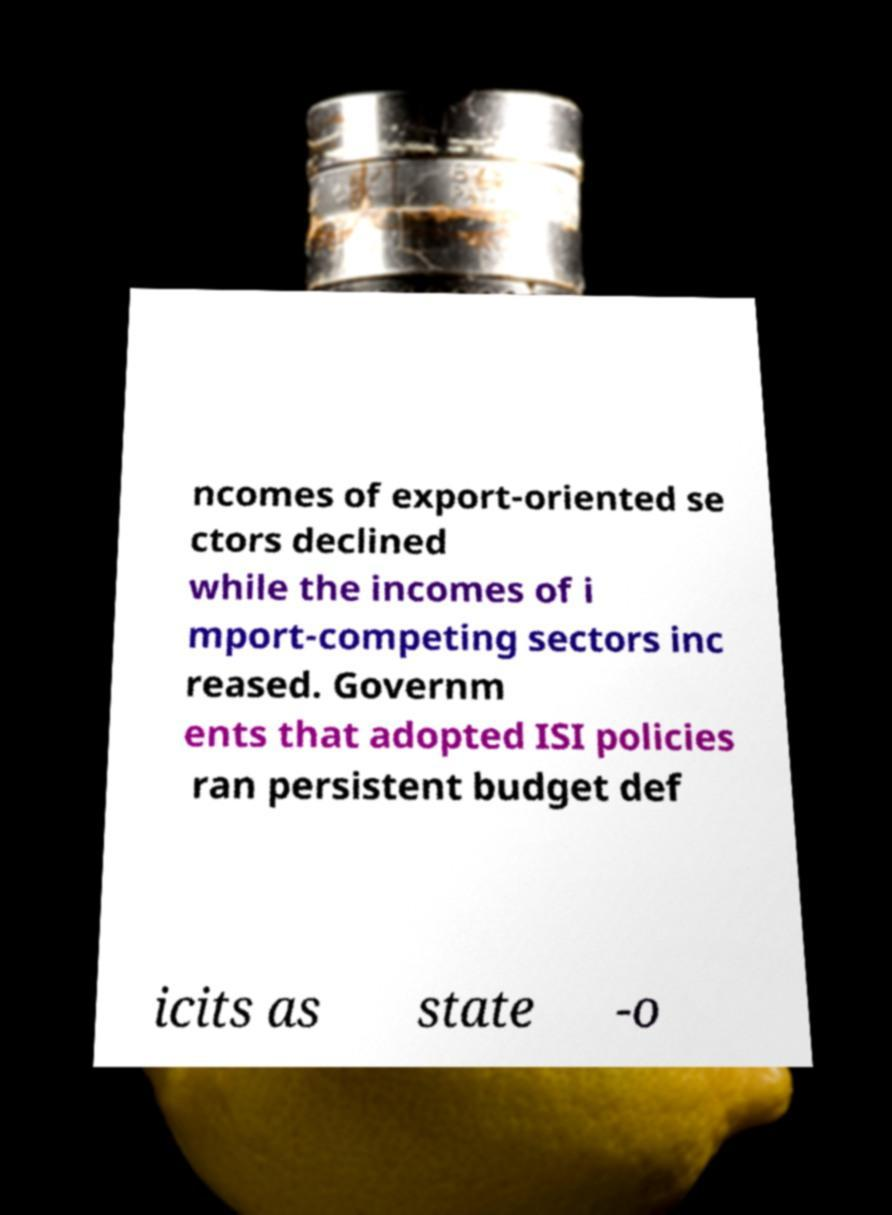Please read and relay the text visible in this image. What does it say? ncomes of export-oriented se ctors declined while the incomes of i mport-competing sectors inc reased. Governm ents that adopted ISI policies ran persistent budget def icits as state -o 